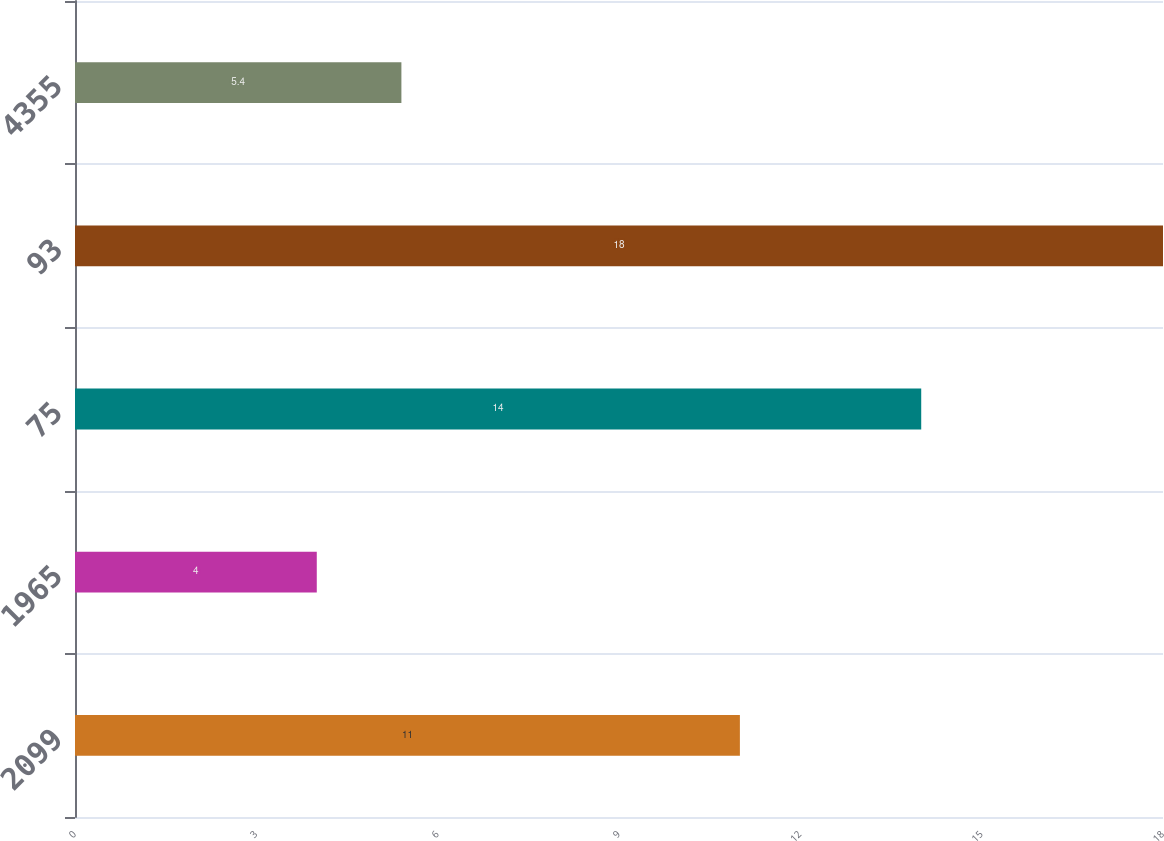<chart> <loc_0><loc_0><loc_500><loc_500><bar_chart><fcel>2099<fcel>1965<fcel>75<fcel>93<fcel>4355<nl><fcel>11<fcel>4<fcel>14<fcel>18<fcel>5.4<nl></chart> 